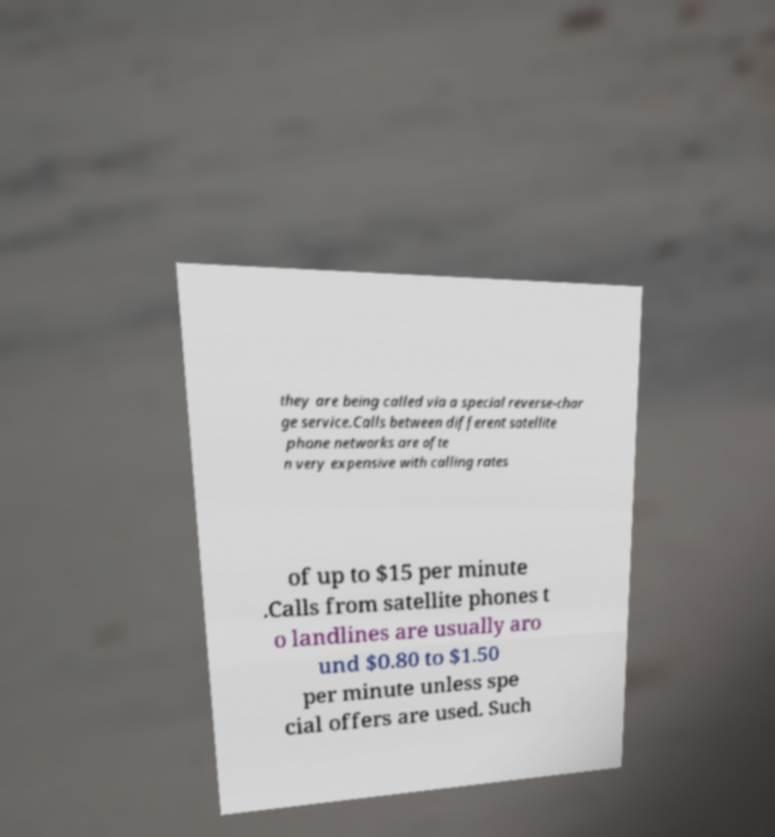Could you assist in decoding the text presented in this image and type it out clearly? they are being called via a special reverse-char ge service.Calls between different satellite phone networks are ofte n very expensive with calling rates of up to $15 per minute .Calls from satellite phones t o landlines are usually aro und $0.80 to $1.50 per minute unless spe cial offers are used. Such 